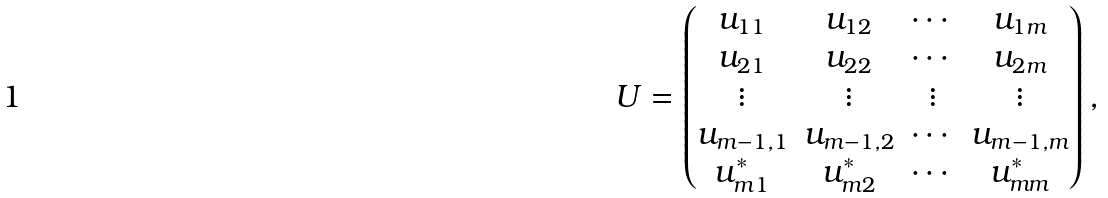<formula> <loc_0><loc_0><loc_500><loc_500>U = \begin{pmatrix} u _ { 1 1 } & u _ { 1 2 } & \cdots & u _ { 1 m } \\ u _ { 2 1 } & u _ { 2 2 } & \cdots & u _ { 2 m } \\ \vdots & \vdots & \vdots & \vdots \\ u _ { m - 1 , 1 } & u _ { m - 1 , 2 } & \cdots & u _ { m - 1 , m } \\ u ^ { * } _ { m 1 } & u ^ { * } _ { m 2 } & \cdots & u ^ { * } _ { m m } \\ \end{pmatrix} ,</formula> 